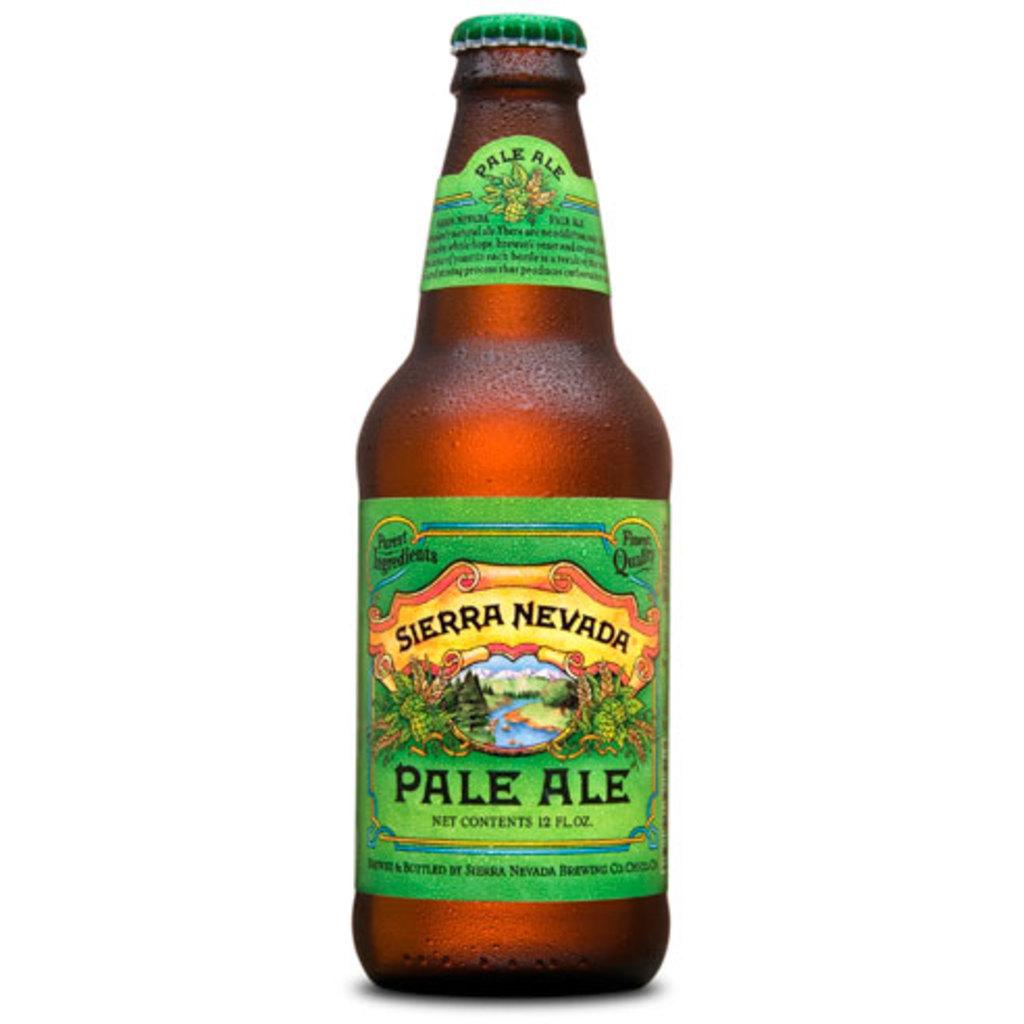What kind of ale is this?
Keep it short and to the point. Pale. How many ounces are in this?
Offer a terse response. 12. 